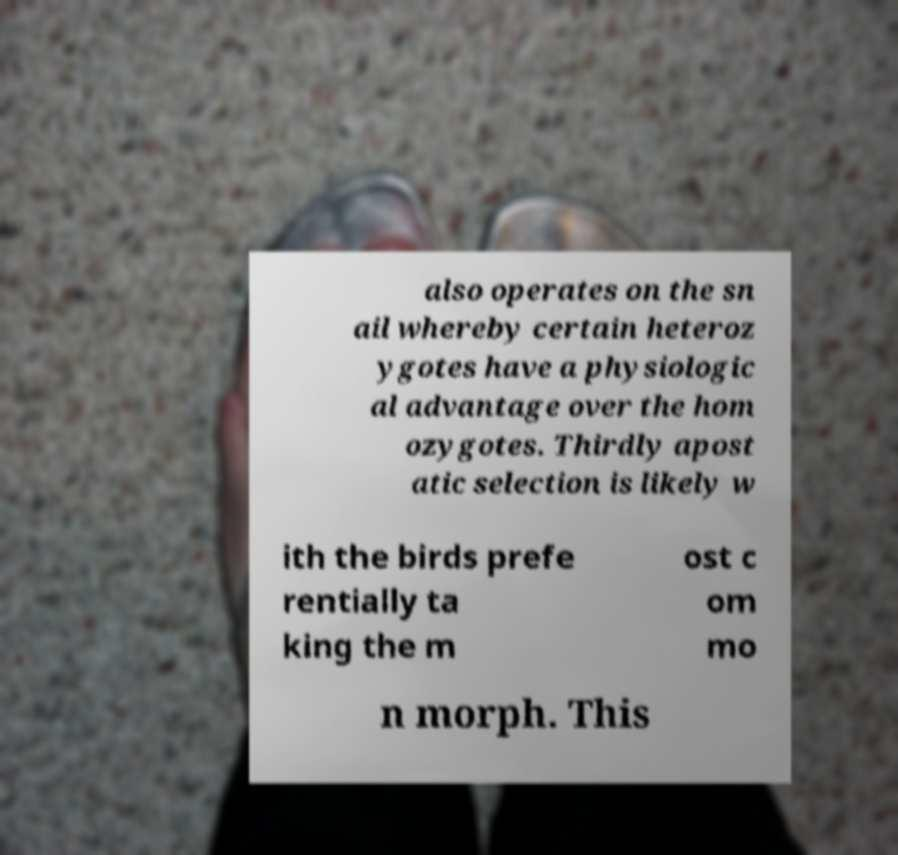What messages or text are displayed in this image? I need them in a readable, typed format. also operates on the sn ail whereby certain heteroz ygotes have a physiologic al advantage over the hom ozygotes. Thirdly apost atic selection is likely w ith the birds prefe rentially ta king the m ost c om mo n morph. This 